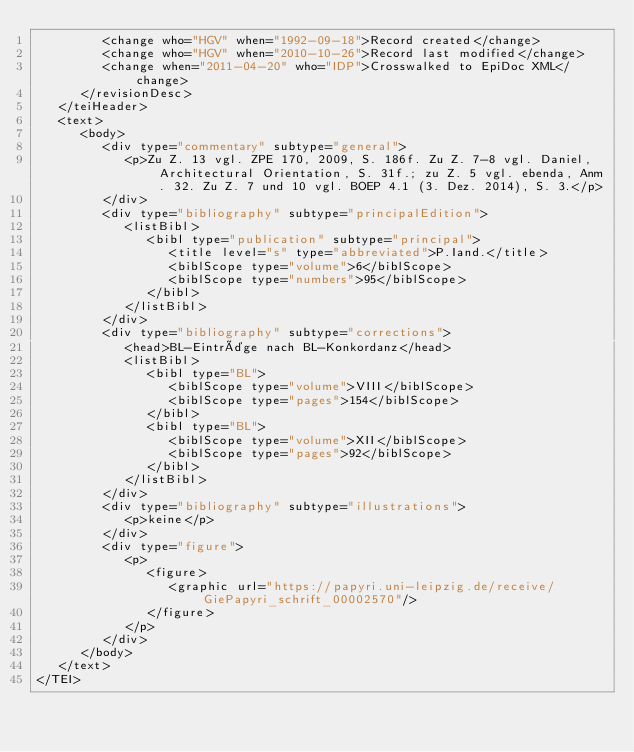<code> <loc_0><loc_0><loc_500><loc_500><_XML_>         <change who="HGV" when="1992-09-18">Record created</change>
         <change who="HGV" when="2010-10-26">Record last modified</change>
         <change when="2011-04-20" who="IDP">Crosswalked to EpiDoc XML</change>
      </revisionDesc>
   </teiHeader>
   <text>
      <body>
         <div type="commentary" subtype="general">
            <p>Zu Z. 13 vgl. ZPE 170, 2009, S. 186f. Zu Z. 7-8 vgl. Daniel, Architectural Orientation, S. 31f.; zu Z. 5 vgl. ebenda, Anm. 32. Zu Z. 7 und 10 vgl. BOEP 4.1 (3. Dez. 2014), S. 3.</p>
         </div>
         <div type="bibliography" subtype="principalEdition">
            <listBibl>
               <bibl type="publication" subtype="principal">
                  <title level="s" type="abbreviated">P.Iand.</title>
                  <biblScope type="volume">6</biblScope>
                  <biblScope type="numbers">95</biblScope>
               </bibl>
            </listBibl>
         </div>
         <div type="bibliography" subtype="corrections">
            <head>BL-Einträge nach BL-Konkordanz</head>
            <listBibl>
               <bibl type="BL">
                  <biblScope type="volume">VIII</biblScope>
                  <biblScope type="pages">154</biblScope>
               </bibl>
               <bibl type="BL">
                  <biblScope type="volume">XII</biblScope>
                  <biblScope type="pages">92</biblScope>
               </bibl>
            </listBibl>
         </div>
         <div type="bibliography" subtype="illustrations">
            <p>keine</p>
         </div>
         <div type="figure">
            <p>
               <figure>
                  <graphic url="https://papyri.uni-leipzig.de/receive/GiePapyri_schrift_00002570"/>
               </figure>
            </p>
         </div>
      </body>
   </text>
</TEI>
</code> 